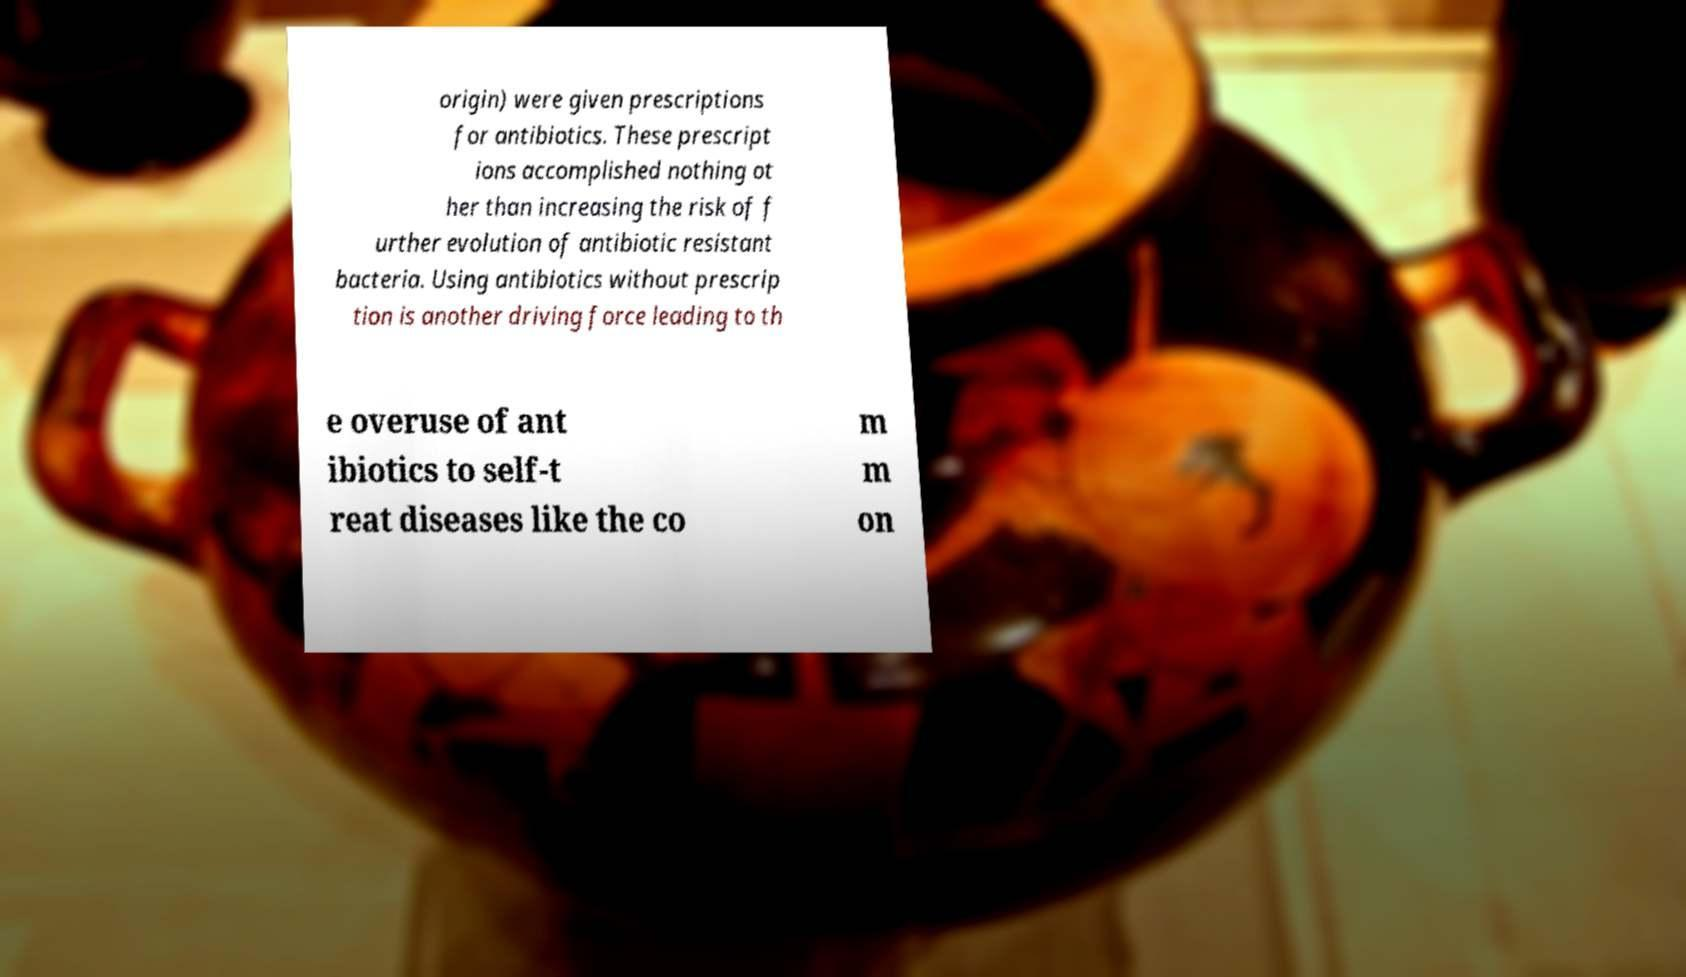Can you read and provide the text displayed in the image?This photo seems to have some interesting text. Can you extract and type it out for me? origin) were given prescriptions for antibiotics. These prescript ions accomplished nothing ot her than increasing the risk of f urther evolution of antibiotic resistant bacteria. Using antibiotics without prescrip tion is another driving force leading to th e overuse of ant ibiotics to self-t reat diseases like the co m m on 